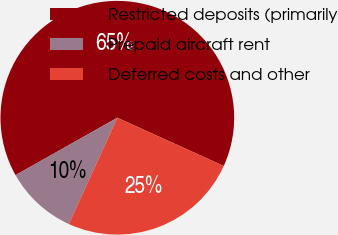Convert chart. <chart><loc_0><loc_0><loc_500><loc_500><pie_chart><fcel>Restricted deposits (primarily<fcel>Prepaid aircraft rent<fcel>Deferred costs and other<nl><fcel>64.95%<fcel>10.02%<fcel>25.04%<nl></chart> 